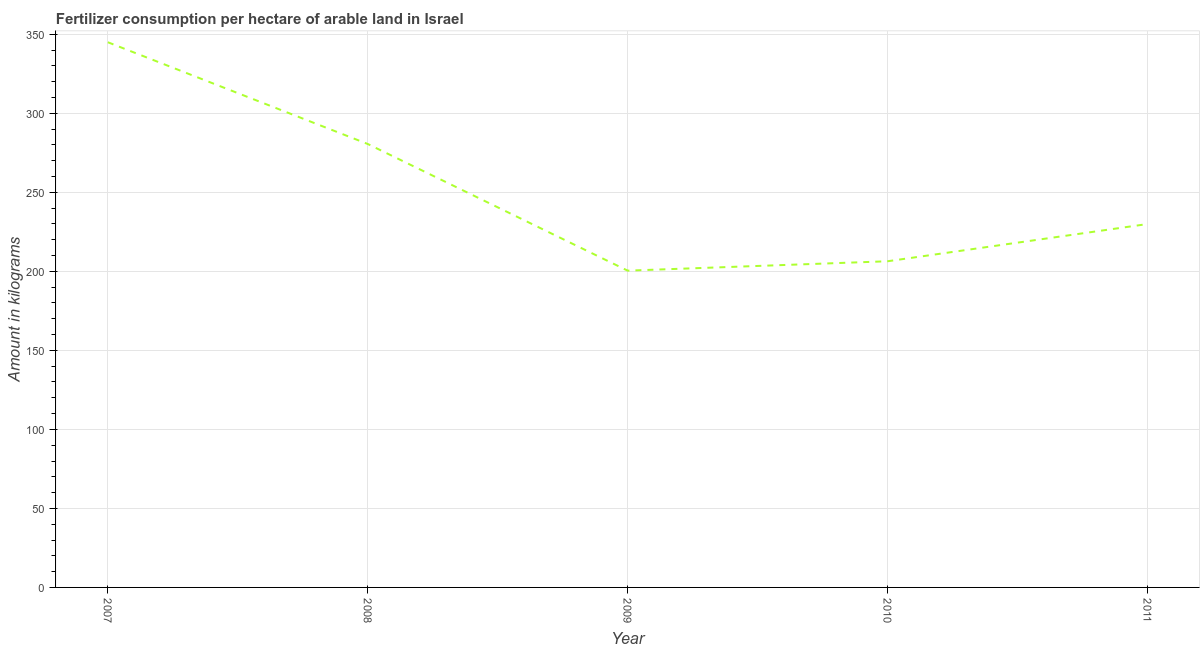What is the amount of fertilizer consumption in 2009?
Your answer should be compact. 200.46. Across all years, what is the maximum amount of fertilizer consumption?
Your response must be concise. 345. Across all years, what is the minimum amount of fertilizer consumption?
Your answer should be compact. 200.46. In which year was the amount of fertilizer consumption minimum?
Your answer should be compact. 2009. What is the sum of the amount of fertilizer consumption?
Your response must be concise. 1262.44. What is the difference between the amount of fertilizer consumption in 2009 and 2011?
Your answer should be compact. -29.5. What is the average amount of fertilizer consumption per year?
Your answer should be compact. 252.49. What is the median amount of fertilizer consumption?
Keep it short and to the point. 229.96. What is the ratio of the amount of fertilizer consumption in 2008 to that in 2011?
Offer a terse response. 1.22. What is the difference between the highest and the second highest amount of fertilizer consumption?
Keep it short and to the point. 64.38. What is the difference between the highest and the lowest amount of fertilizer consumption?
Your answer should be compact. 144.54. In how many years, is the amount of fertilizer consumption greater than the average amount of fertilizer consumption taken over all years?
Your response must be concise. 2. How many lines are there?
Give a very brief answer. 1. Does the graph contain grids?
Provide a short and direct response. Yes. What is the title of the graph?
Your response must be concise. Fertilizer consumption per hectare of arable land in Israel . What is the label or title of the Y-axis?
Your answer should be compact. Amount in kilograms. What is the Amount in kilograms in 2007?
Provide a succinct answer. 345. What is the Amount in kilograms of 2008?
Ensure brevity in your answer.  280.61. What is the Amount in kilograms in 2009?
Provide a short and direct response. 200.46. What is the Amount in kilograms in 2010?
Offer a very short reply. 206.4. What is the Amount in kilograms of 2011?
Give a very brief answer. 229.96. What is the difference between the Amount in kilograms in 2007 and 2008?
Make the answer very short. 64.38. What is the difference between the Amount in kilograms in 2007 and 2009?
Provide a short and direct response. 144.54. What is the difference between the Amount in kilograms in 2007 and 2010?
Make the answer very short. 138.59. What is the difference between the Amount in kilograms in 2007 and 2011?
Offer a very short reply. 115.03. What is the difference between the Amount in kilograms in 2008 and 2009?
Provide a succinct answer. 80.15. What is the difference between the Amount in kilograms in 2008 and 2010?
Offer a very short reply. 74.21. What is the difference between the Amount in kilograms in 2008 and 2011?
Your answer should be compact. 50.65. What is the difference between the Amount in kilograms in 2009 and 2010?
Provide a short and direct response. -5.94. What is the difference between the Amount in kilograms in 2009 and 2011?
Your answer should be compact. -29.5. What is the difference between the Amount in kilograms in 2010 and 2011?
Provide a succinct answer. -23.56. What is the ratio of the Amount in kilograms in 2007 to that in 2008?
Keep it short and to the point. 1.23. What is the ratio of the Amount in kilograms in 2007 to that in 2009?
Your answer should be compact. 1.72. What is the ratio of the Amount in kilograms in 2007 to that in 2010?
Make the answer very short. 1.67. What is the ratio of the Amount in kilograms in 2007 to that in 2011?
Your answer should be compact. 1.5. What is the ratio of the Amount in kilograms in 2008 to that in 2010?
Provide a short and direct response. 1.36. What is the ratio of the Amount in kilograms in 2008 to that in 2011?
Provide a short and direct response. 1.22. What is the ratio of the Amount in kilograms in 2009 to that in 2010?
Offer a terse response. 0.97. What is the ratio of the Amount in kilograms in 2009 to that in 2011?
Provide a succinct answer. 0.87. What is the ratio of the Amount in kilograms in 2010 to that in 2011?
Your answer should be very brief. 0.9. 